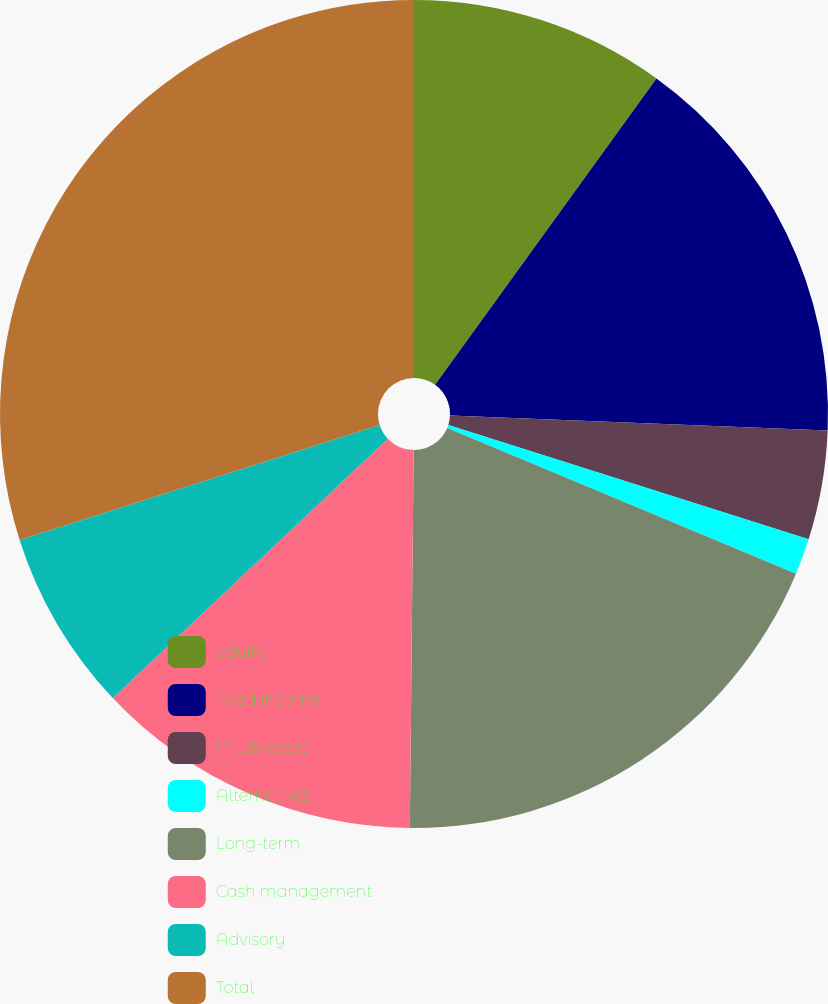<chart> <loc_0><loc_0><loc_500><loc_500><pie_chart><fcel>Equity<fcel>Fixed income<fcel>Multi-asset<fcel>Alternatives<fcel>Long-term<fcel>Cash management<fcel>Advisory<fcel>Total<nl><fcel>9.96%<fcel>15.67%<fcel>4.26%<fcel>1.41%<fcel>18.86%<fcel>12.81%<fcel>7.11%<fcel>29.92%<nl></chart> 